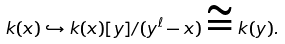Convert formula to latex. <formula><loc_0><loc_0><loc_500><loc_500>k ( x ) \hookrightarrow k ( x ) [ y ] / ( y ^ { \ell } - x ) \cong k ( y ) .</formula> 